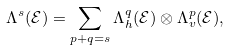Convert formula to latex. <formula><loc_0><loc_0><loc_500><loc_500>\Lambda ^ { s } ( \mathcal { E } ) = \sum _ { p + q = s } \Lambda _ { h } ^ { q } ( \mathcal { E } ) \otimes \Lambda _ { v } ^ { p } ( \mathcal { E } ) ,</formula> 